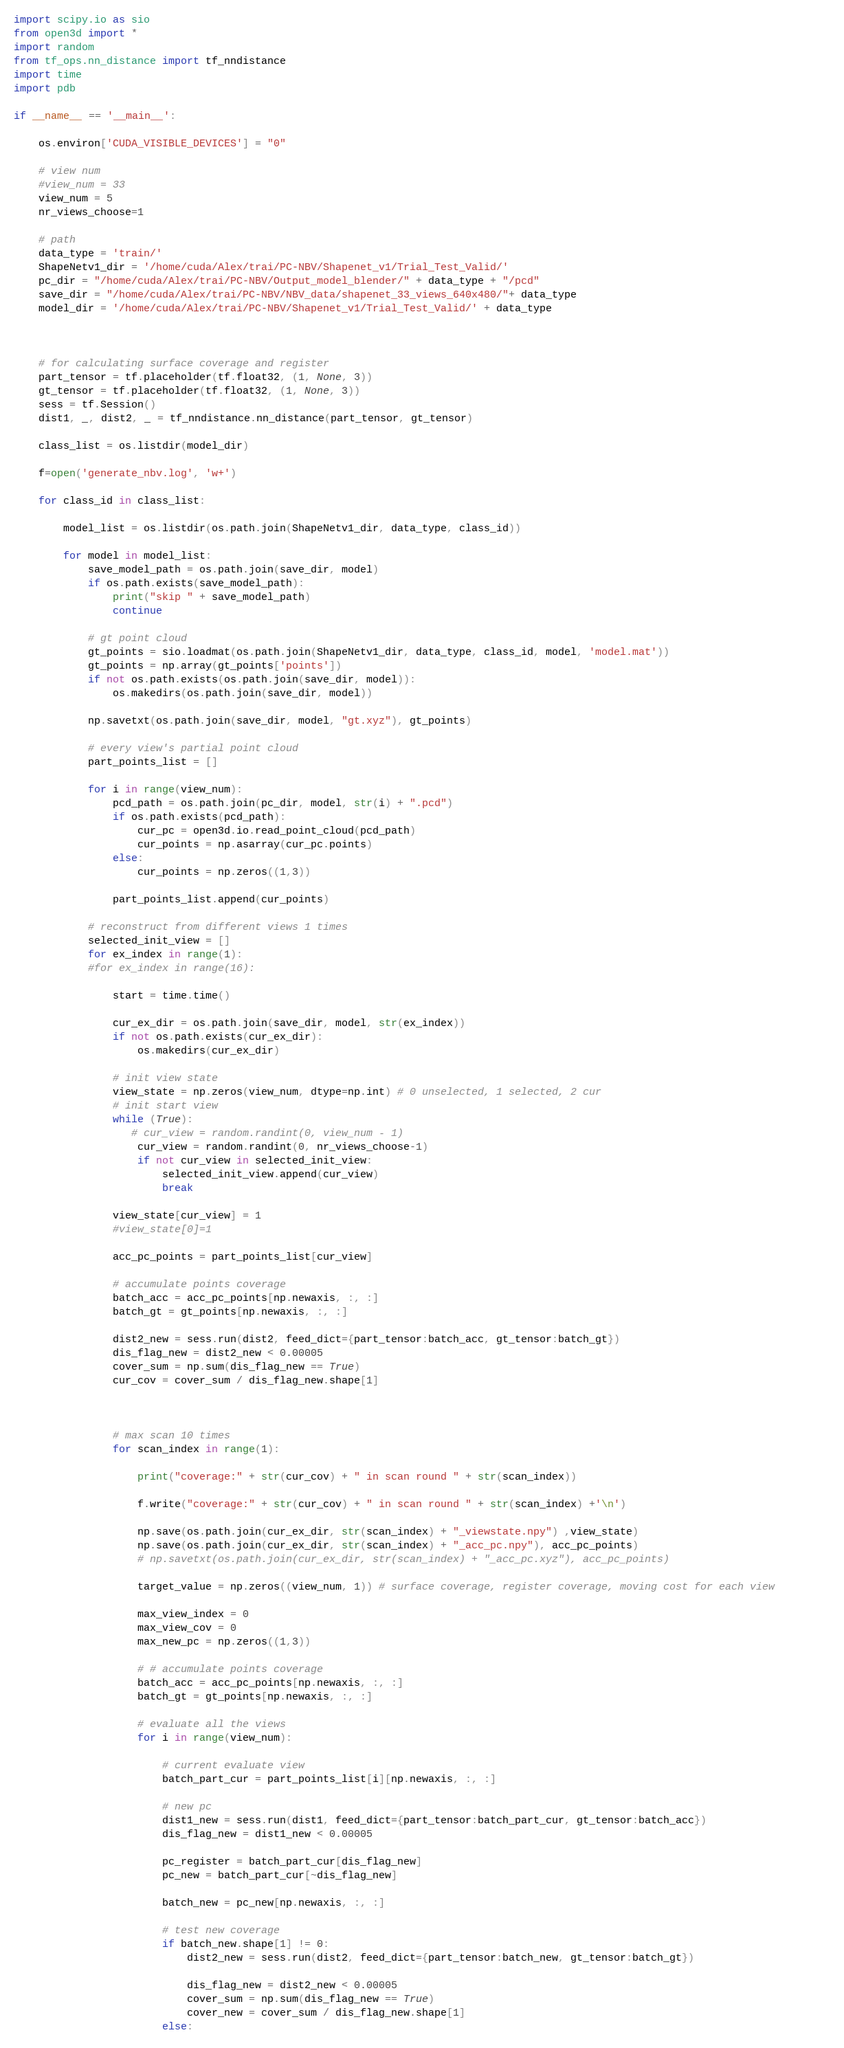<code> <loc_0><loc_0><loc_500><loc_500><_Python_>import scipy.io as sio
from open3d import *
import random
from tf_ops.nn_distance import tf_nndistance 
import time
import pdb

if __name__ == '__main__':

    os.environ['CUDA_VISIBLE_DEVICES'] = "0"
    
    # view num
    #view_num = 33
    view_num = 5
    nr_views_choose=1

    # path
    data_type = 'train/'
    ShapeNetv1_dir = '/home/cuda/Alex/trai/PC-NBV/Shapenet_v1/Trial_Test_Valid/'    
    pc_dir = "/home/cuda/Alex/trai/PC-NBV/Output_model_blender/" + data_type + "/pcd"
    save_dir = "/home/cuda/Alex/trai/PC-NBV/NBV_data/shapenet_33_views_640x480/"+ data_type
    model_dir = '/home/cuda/Alex/trai/PC-NBV/Shapenet_v1/Trial_Test_Valid/' + data_type

    

    # for calculating surface coverage and register
    part_tensor = tf.placeholder(tf.float32, (1, None, 3))
    gt_tensor = tf.placeholder(tf.float32, (1, None, 3))
    sess = tf.Session()
    dist1, _, dist2, _ = tf_nndistance.nn_distance(part_tensor, gt_tensor)

    class_list = os.listdir(model_dir)

    f=open('generate_nbv.log', 'w+')

    for class_id in class_list:

        model_list = os.listdir(os.path.join(ShapeNetv1_dir, data_type, class_id))

        for model in model_list:
            save_model_path = os.path.join(save_dir, model)
            if os.path.exists(save_model_path):
                print("skip " + save_model_path)
                continue

            # gt point cloud
            gt_points = sio.loadmat(os.path.join(ShapeNetv1_dir, data_type, class_id, model, 'model.mat'))
            gt_points = np.array(gt_points['points'])
            if not os.path.exists(os.path.join(save_dir, model)):
                os.makedirs(os.path.join(save_dir, model))

            np.savetxt(os.path.join(save_dir, model, "gt.xyz"), gt_points)    

            # every view's partial point cloud
            part_points_list = []
            
            for i in range(view_num):
                pcd_path = os.path.join(pc_dir, model, str(i) + ".pcd")
                if os.path.exists(pcd_path):
                    cur_pc = open3d.io.read_point_cloud(pcd_path)
                    cur_points = np.asarray(cur_pc.points)  
                else:
                    cur_points = np.zeros((1,3))

                part_points_list.append(cur_points)

            # reconstruct from different views 1 times
            selected_init_view = []
            for ex_index in range(1): 
            #for ex_index in range(16):  

                start = time.time() 

                cur_ex_dir = os.path.join(save_dir, model, str(ex_index))
                if not os.path.exists(cur_ex_dir):
                    os.makedirs(cur_ex_dir) 

                # init view state
                view_state = np.zeros(view_num, dtype=np.int) # 0 unselected, 1 selected, 2 cur
                # init start view
                while (True):
                   # cur_view = random.randint(0, view_num - 1)
                    cur_view = random.randint(0, nr_views_choose-1)
                    if not cur_view in selected_init_view:
                        selected_init_view.append(cur_view)
                        break   

                view_state[cur_view] = 1
                #view_state[0]=1

                acc_pc_points = part_points_list[cur_view]  

                # accumulate points coverage
                batch_acc = acc_pc_points[np.newaxis, :, :]
                batch_gt = gt_points[np.newaxis, :, :]

                dist2_new = sess.run(dist2, feed_dict={part_tensor:batch_acc, gt_tensor:batch_gt})      
                dis_flag_new = dist2_new < 0.00005
                cover_sum = np.sum(dis_flag_new == True)
                cur_cov = cover_sum / dis_flag_new.shape[1]

                

                # max scan 10 times
                for scan_index in range(1):    

                    print("coverage:" + str(cur_cov) + " in scan round " + str(scan_index)) 

                    f.write("coverage:" + str(cur_cov) + " in scan round " + str(scan_index) +'\n')

                    np.save(os.path.join(cur_ex_dir, str(scan_index) + "_viewstate.npy") ,view_state)
                    np.save(os.path.join(cur_ex_dir, str(scan_index) + "_acc_pc.npy"), acc_pc_points)
                    # np.savetxt(os.path.join(cur_ex_dir, str(scan_index) + "_acc_pc.xyz"), acc_pc_points)    

                    target_value = np.zeros((view_num, 1)) # surface coverage, register coverage, moving cost for each view         

                    max_view_index = 0
                    max_view_cov = 0
                    max_new_pc = np.zeros((1,3))

                    # # accumulate points coverage
                    batch_acc = acc_pc_points[np.newaxis, :, :]
                    batch_gt = gt_points[np.newaxis, :, :]
                    
                    # evaluate all the views
                    for i in range(view_num):   

                        # current evaluate view
                        batch_part_cur = part_points_list[i][np.newaxis, :, :]  

                        # new pc
                        dist1_new = sess.run(dist1, feed_dict={part_tensor:batch_part_cur, gt_tensor:batch_acc})
                        dis_flag_new = dist1_new < 0.00005  

                        pc_register = batch_part_cur[dis_flag_new]
                        pc_new = batch_part_cur[~dis_flag_new]

                        batch_new = pc_new[np.newaxis, :, :]    

                        # test new coverage
                        if batch_new.shape[1] != 0:
                            dist2_new = sess.run(dist2, feed_dict={part_tensor:batch_new, gt_tensor:batch_gt})      

                            dis_flag_new = dist2_new < 0.00005
                            cover_sum = np.sum(dis_flag_new == True)
                            cover_new = cover_sum / dis_flag_new.shape[1]
                        else:</code> 